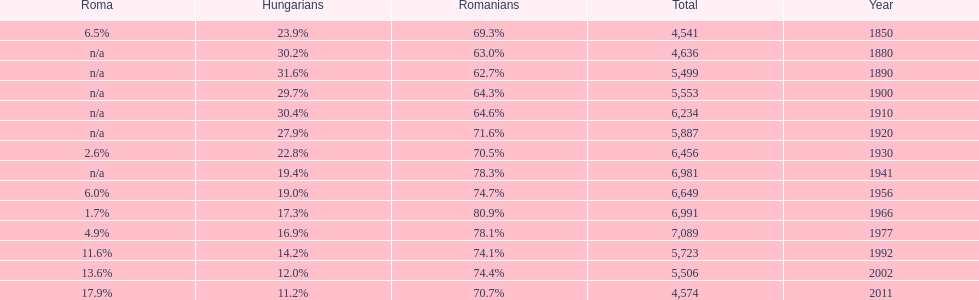Which year is previous to the year that had 74.1% in romanian population? 1977. 